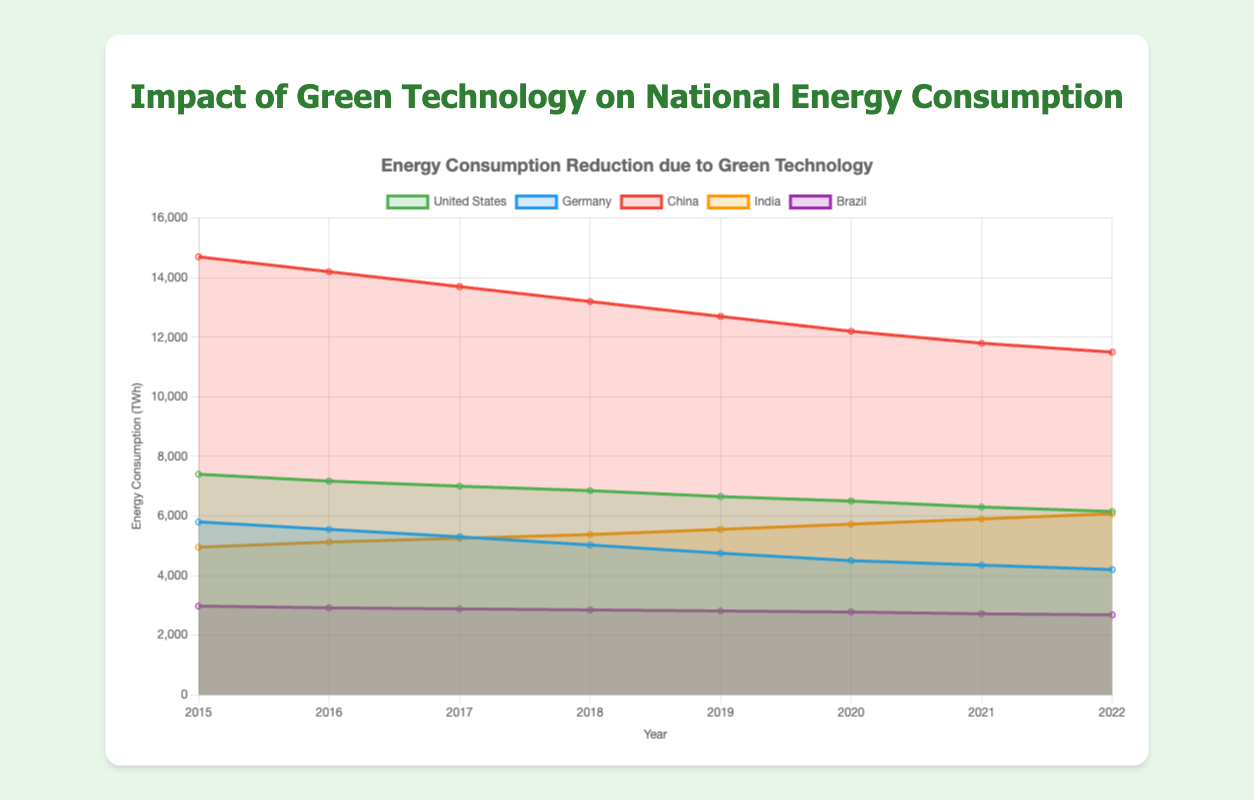What is the title of the figure? The title of the figure is displayed at the top, above the chart. It reads "Energy Consumption Reduction due to Green Technology".
Answer: Energy Consumption Reduction due to Green Technology What are the labels on the x-axis and y-axis? The labels on the axes are displayed next to the respective axes. The x-axis is labeled "Year", and the y-axis is labeled "Energy Consumption (TWh)".
Answer: Year; Energy Consumption (TWh) Which country's energy consumption decreased the most between 2015 and 2022? To determine which country's energy consumption decreased the most, calculate the difference in energy consumption values from 2015 and 2022 for each country (taking into account the green technology impact). The United States had the highest decrease.
Answer: United States How did Germany's green technology impact on energy consumption change from 2015 to 2022? Look at the green technology impact values for Germany in 2015 and 2022. It increased from 200 TWh in 2015 to 600 TWh in 2022.
Answer: Increased from 200 TWh to 600 TWh In which year did India see the highest green technology impact? By examining the green technology impact values for India across the years, the highest value is found in 2022, which is 225 TWh.
Answer: 2022 How does the total energy consumption reduction for Brazil compare to that of Germany in 2019? Calculate the total energy consumption reduction by subtracting the green technology impact from the total energy consumption for both countries in 2019. For Brazil: 2875 - 65 = 2810 TWh; for Germany: 5200 - 450 = 4750 TWh. Germany's reduction is higher.
Answer: Germany's reduction is higher What trend can be observed in China's energy consumption after the implementation of green technologies from 2015 to 2022? Observe the values of China's energy consumption from 2015 to 2022, adjusted for green technology impact. The consumption consistently decreases every year.
Answer: Consistent decrease Which country had the least impact from green technology in 2018? Compare the green technology impact values for each country in 2018. Brazil had the least impact with 55 TWh.
Answer: Brazil 